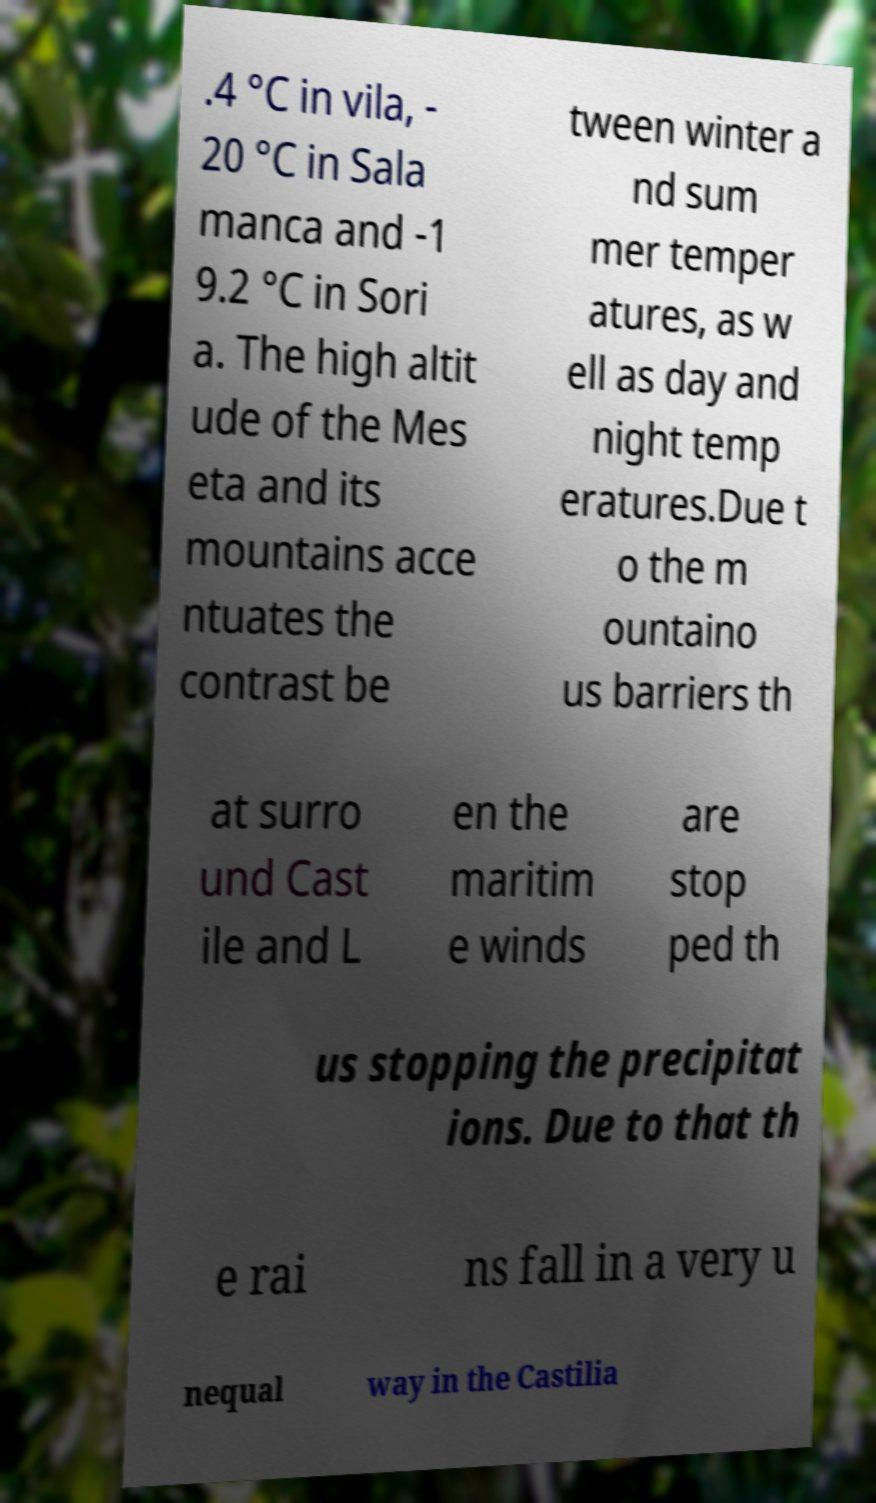Please identify and transcribe the text found in this image. .4 °C in vila, - 20 °C in Sala manca and -1 9.2 °C in Sori a. The high altit ude of the Mes eta and its mountains acce ntuates the contrast be tween winter a nd sum mer temper atures, as w ell as day and night temp eratures.Due t o the m ountaino us barriers th at surro und Cast ile and L en the maritim e winds are stop ped th us stopping the precipitat ions. Due to that th e rai ns fall in a very u nequal way in the Castilia 